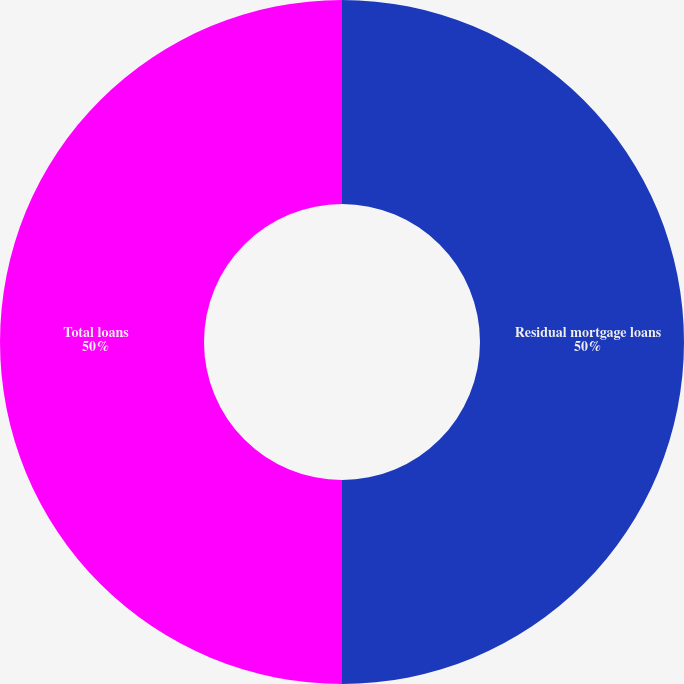Convert chart to OTSL. <chart><loc_0><loc_0><loc_500><loc_500><pie_chart><fcel>Residual mortgage loans<fcel>Total loans<nl><fcel>50.0%<fcel>50.0%<nl></chart> 